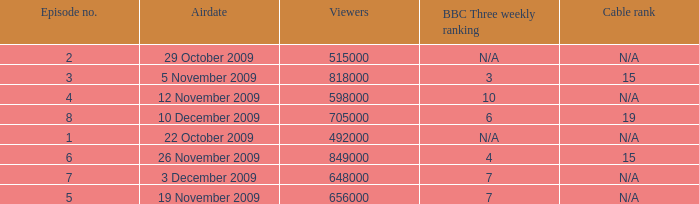What is the cable rank for the airdate of 10 december 2009? 19.0. 